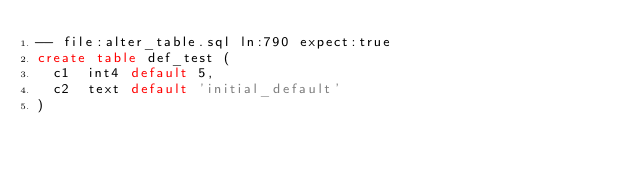Convert code to text. <code><loc_0><loc_0><loc_500><loc_500><_SQL_>-- file:alter_table.sql ln:790 expect:true
create table def_test (
	c1	int4 default 5,
	c2	text default 'initial_default'
)
</code> 